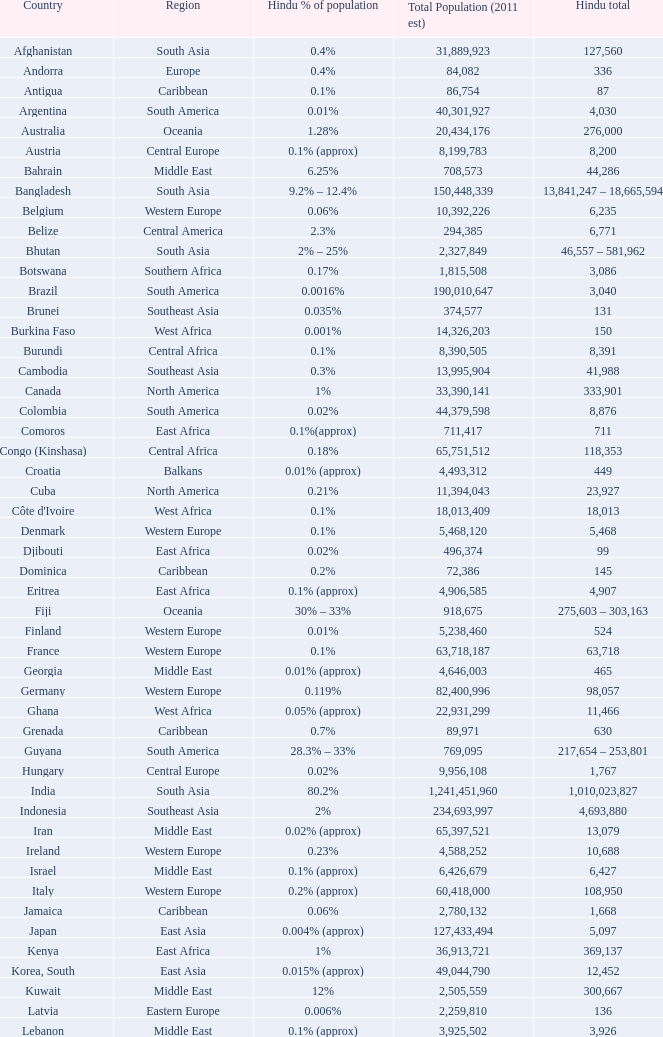Total Population (2011 est) larger than 30,262,610, and a Hindu total of 63,718 involves what country? France. 